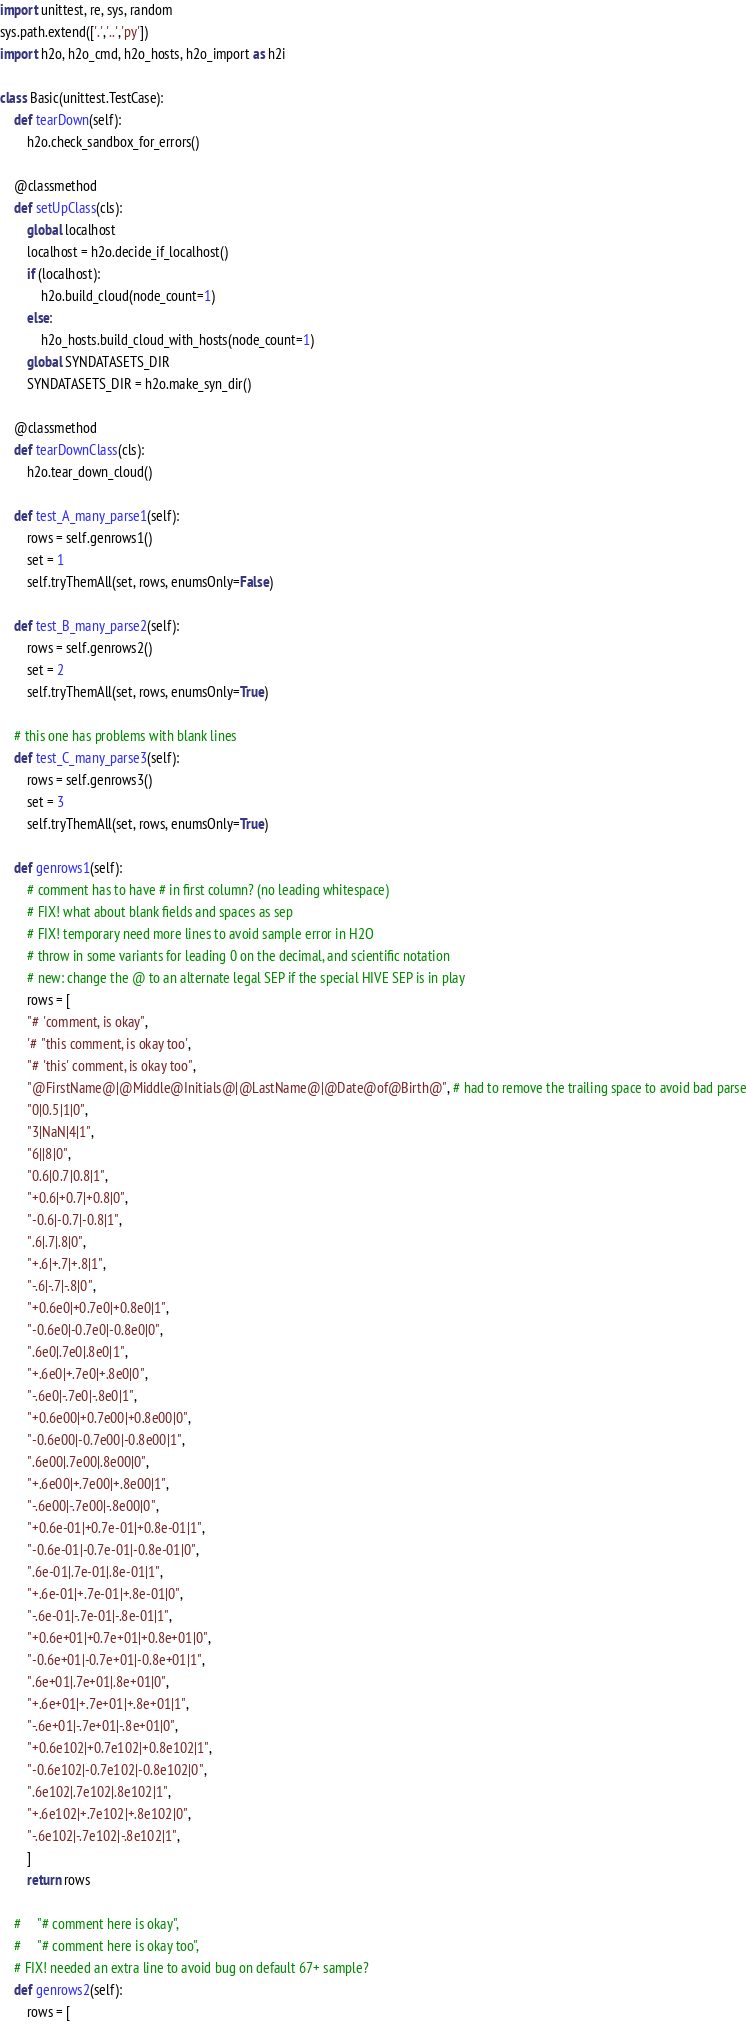Convert code to text. <code><loc_0><loc_0><loc_500><loc_500><_Python_>import unittest, re, sys, random
sys.path.extend(['.','..','py'])
import h2o, h2o_cmd, h2o_hosts, h2o_import as h2i

class Basic(unittest.TestCase):
    def tearDown(self):
        h2o.check_sandbox_for_errors()

    @classmethod
    def setUpClass(cls):
        global localhost
        localhost = h2o.decide_if_localhost()
        if (localhost):
            h2o.build_cloud(node_count=1) 
        else:
            h2o_hosts.build_cloud_with_hosts(node_count=1) 
        global SYNDATASETS_DIR
        SYNDATASETS_DIR = h2o.make_syn_dir()

    @classmethod 
    def tearDownClass(cls): 
        h2o.tear_down_cloud()

    def test_A_many_parse1(self):
        rows = self.genrows1()
        set = 1
        self.tryThemAll(set, rows, enumsOnly=False)

    def test_B_many_parse2(self):
        rows = self.genrows2()
        set = 2
        self.tryThemAll(set, rows, enumsOnly=True)

    # this one has problems with blank lines
    def test_C_many_parse3(self):
        rows = self.genrows3()
        set = 3
        self.tryThemAll(set, rows, enumsOnly=True)

    def genrows1(self):
        # comment has to have # in first column? (no leading whitespace)
        # FIX! what about blank fields and spaces as sep
        # FIX! temporary need more lines to avoid sample error in H2O
        # throw in some variants for leading 0 on the decimal, and scientific notation
        # new: change the @ to an alternate legal SEP if the special HIVE SEP is in play
        rows = [
        "# 'comment, is okay",
        '# "this comment, is okay too',
        "# 'this' comment, is okay too",
        "@FirstName@|@Middle@Initials@|@LastName@|@Date@of@Birth@", # had to remove the trailing space to avoid bad parse
        "0|0.5|1|0",
        "3|NaN|4|1",
        "6||8|0",
        "0.6|0.7|0.8|1",
        "+0.6|+0.7|+0.8|0",
        "-0.6|-0.7|-0.8|1",
        ".6|.7|.8|0",
        "+.6|+.7|+.8|1",
        "-.6|-.7|-.8|0",
        "+0.6e0|+0.7e0|+0.8e0|1",
        "-0.6e0|-0.7e0|-0.8e0|0",
        ".6e0|.7e0|.8e0|1",
        "+.6e0|+.7e0|+.8e0|0",
        "-.6e0|-.7e0|-.8e0|1",
        "+0.6e00|+0.7e00|+0.8e00|0",
        "-0.6e00|-0.7e00|-0.8e00|1",
        ".6e00|.7e00|.8e00|0",
        "+.6e00|+.7e00|+.8e00|1",
        "-.6e00|-.7e00|-.8e00|0",
        "+0.6e-01|+0.7e-01|+0.8e-01|1",
        "-0.6e-01|-0.7e-01|-0.8e-01|0",
        ".6e-01|.7e-01|.8e-01|1",
        "+.6e-01|+.7e-01|+.8e-01|0",
        "-.6e-01|-.7e-01|-.8e-01|1",
        "+0.6e+01|+0.7e+01|+0.8e+01|0",
        "-0.6e+01|-0.7e+01|-0.8e+01|1",
        ".6e+01|.7e+01|.8e+01|0",
        "+.6e+01|+.7e+01|+.8e+01|1",
        "-.6e+01|-.7e+01|-.8e+01|0",
        "+0.6e102|+0.7e102|+0.8e102|1",
        "-0.6e102|-0.7e102|-0.8e102|0",
        ".6e102|.7e102|.8e102|1",
        "+.6e102|+.7e102|+.8e102|0",
        "-.6e102|-.7e102|-.8e102|1",
        ]
        return rows
    
    #     "# comment here is okay",
    #     "# comment here is okay too",
    # FIX! needed an extra line to avoid bug on default 67+ sample?
    def genrows2(self):
        rows = [</code> 